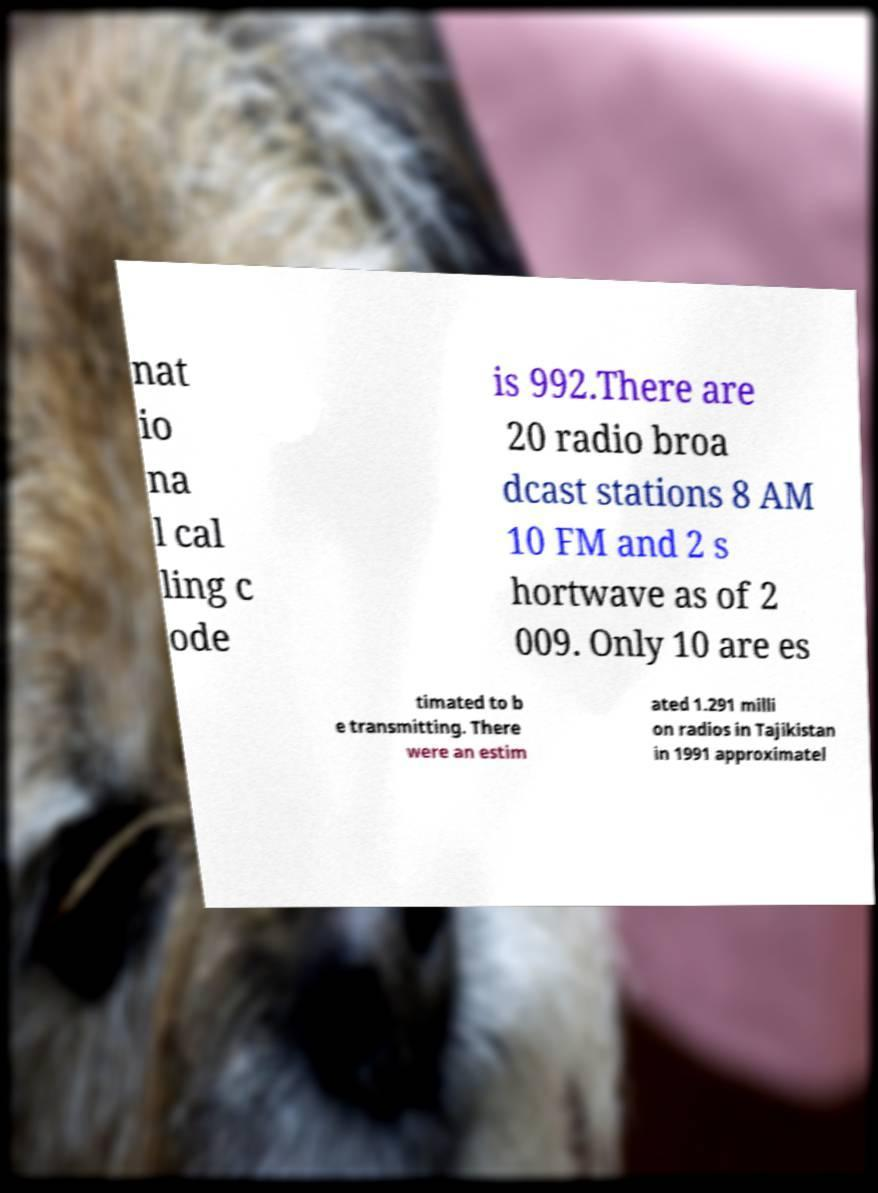For documentation purposes, I need the text within this image transcribed. Could you provide that? nat io na l cal ling c ode is 992.There are 20 radio broa dcast stations 8 AM 10 FM and 2 s hortwave as of 2 009. Only 10 are es timated to b e transmitting. There were an estim ated 1.291 milli on radios in Tajikistan in 1991 approximatel 